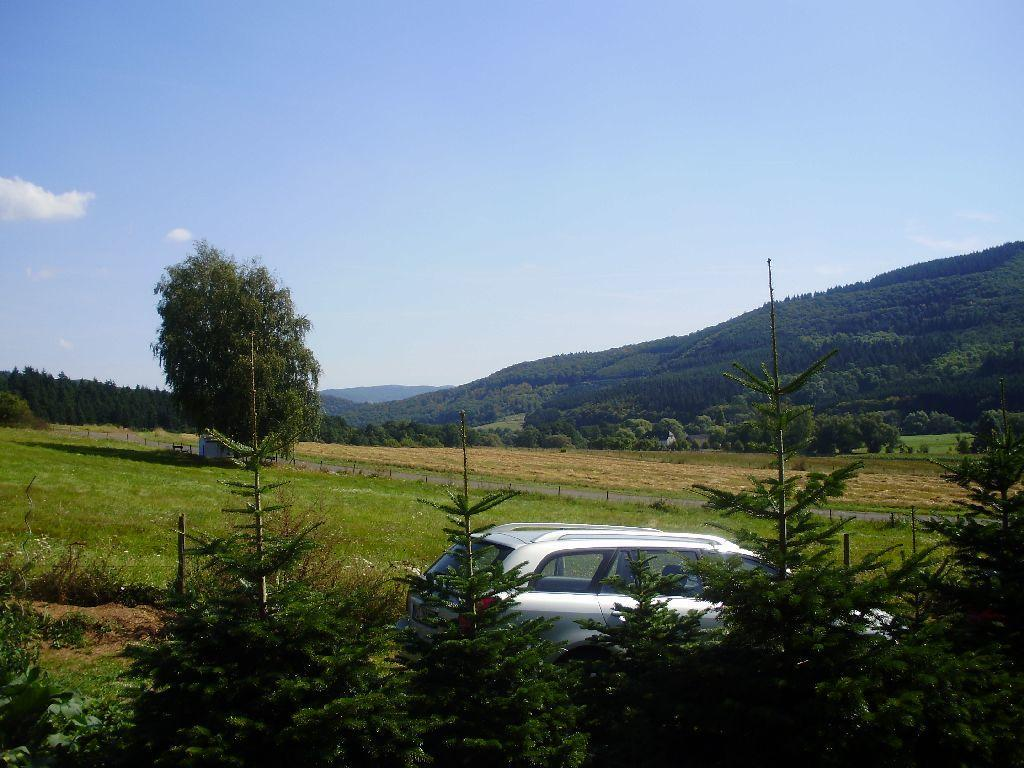Where was the picture taken? The picture was clicked outside. What can be seen in the foreground of the image? There is green grass, plants, trees, and a car in the foreground. What is visible in the background of the image? The sky, hills, more trees, and other unspecified objects are visible in the background. What type of credit can be seen on the car in the image? There is no credit visible on the car in the image. What discovery was made by the waves in the background of the image? There are no waves present in the image; it features hills and trees in the background. 